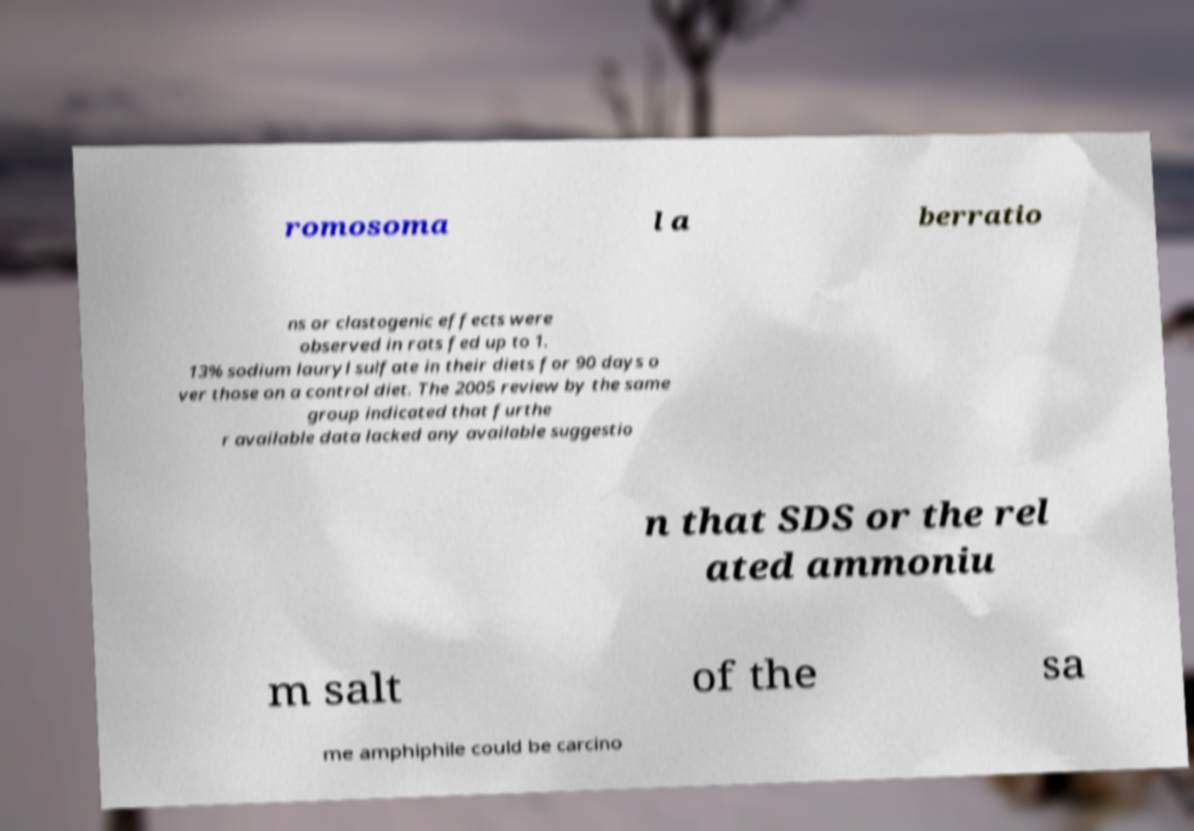I need the written content from this picture converted into text. Can you do that? romosoma l a berratio ns or clastogenic effects were observed in rats fed up to 1. 13% sodium lauryl sulfate in their diets for 90 days o ver those on a control diet. The 2005 review by the same group indicated that furthe r available data lacked any available suggestio n that SDS or the rel ated ammoniu m salt of the sa me amphiphile could be carcino 